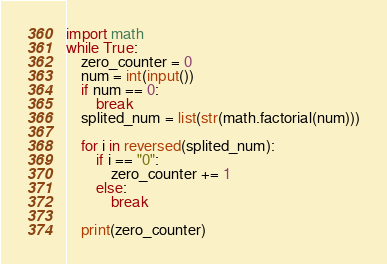Convert code to text. <code><loc_0><loc_0><loc_500><loc_500><_Python_>import math
while True:
    zero_counter = 0
    num = int(input())
    if num == 0:
        break
    splited_num = list(str(math.factorial(num)))

    for i in reversed(splited_num):
        if i == "0":
            zero_counter += 1
        else:
            break

    print(zero_counter)

</code> 